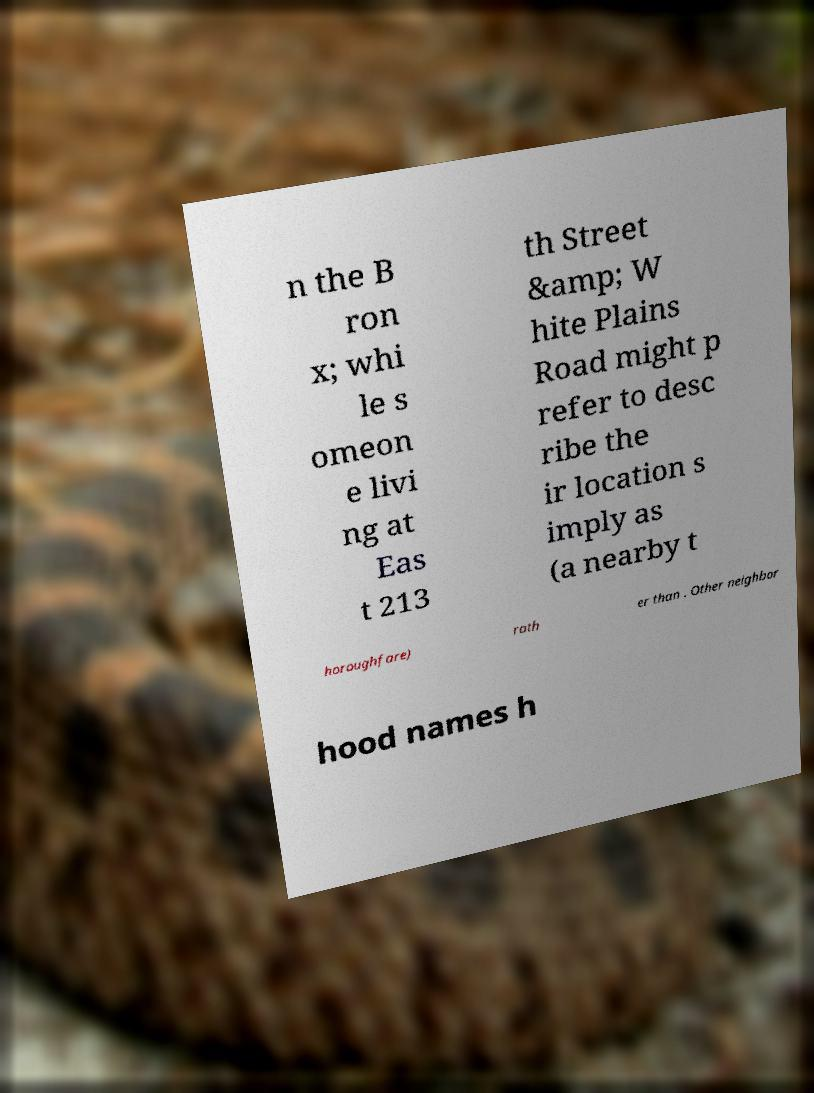There's text embedded in this image that I need extracted. Can you transcribe it verbatim? n the B ron x; whi le s omeon e livi ng at Eas t 213 th Street &amp; W hite Plains Road might p refer to desc ribe the ir location s imply as (a nearby t horoughfare) rath er than . Other neighbor hood names h 